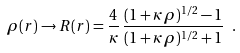Convert formula to latex. <formula><loc_0><loc_0><loc_500><loc_500>\rho ( r ) \rightarrow R ( r ) = \frac { 4 } { \kappa } \, \frac { ( 1 + \kappa \, \rho ) ^ { 1 / 2 } - 1 } { ( 1 + \kappa \, \rho ) ^ { 1 / 2 } + 1 } \ .</formula> 